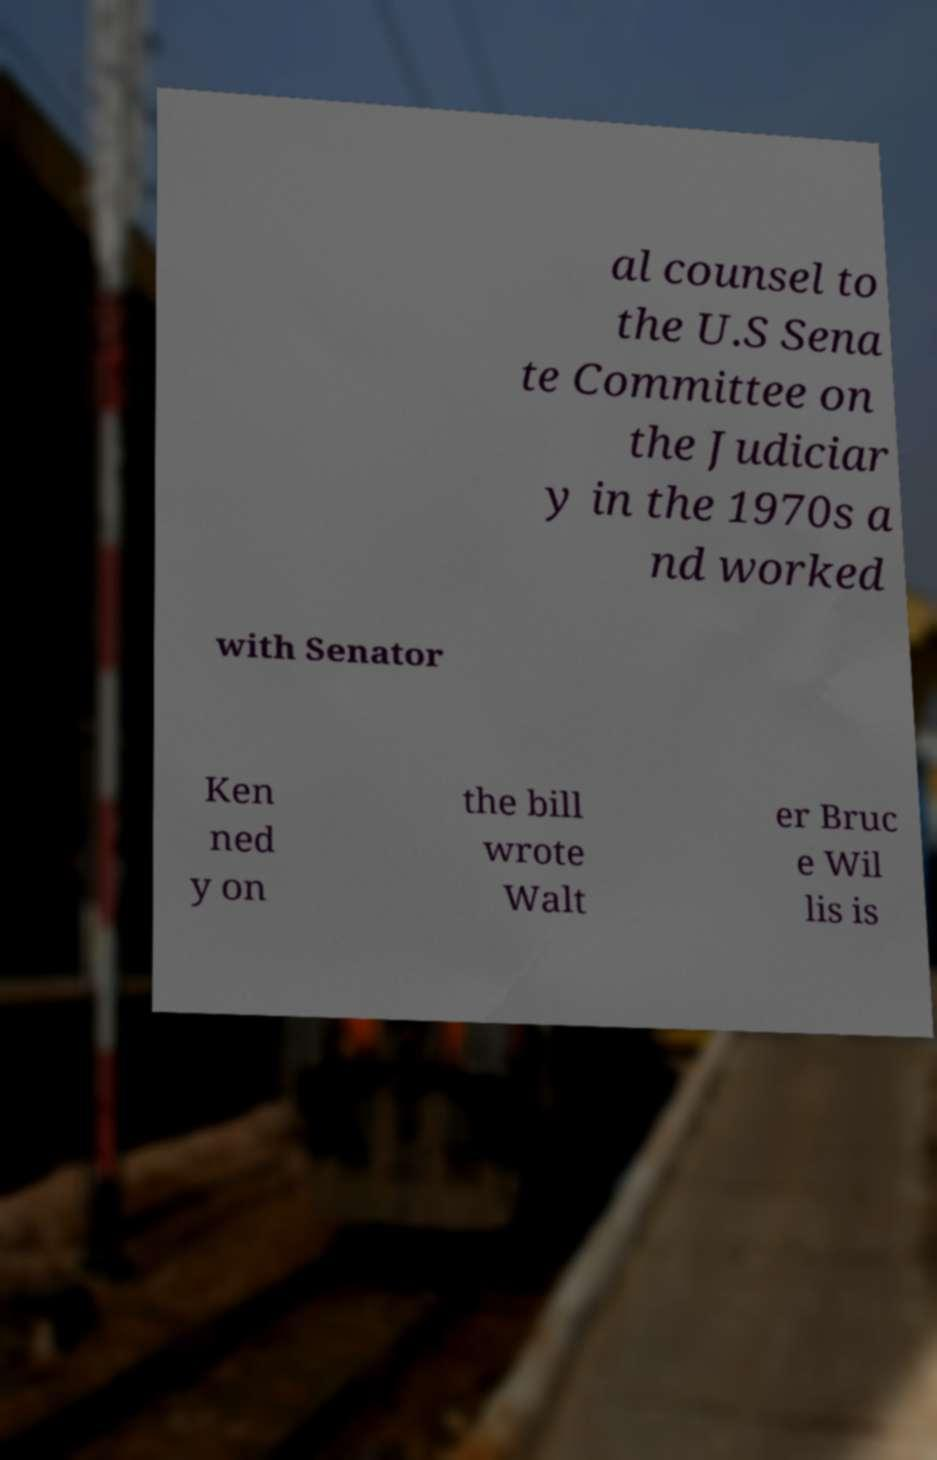Please identify and transcribe the text found in this image. al counsel to the U.S Sena te Committee on the Judiciar y in the 1970s a nd worked with Senator Ken ned y on the bill wrote Walt er Bruc e Wil lis is 